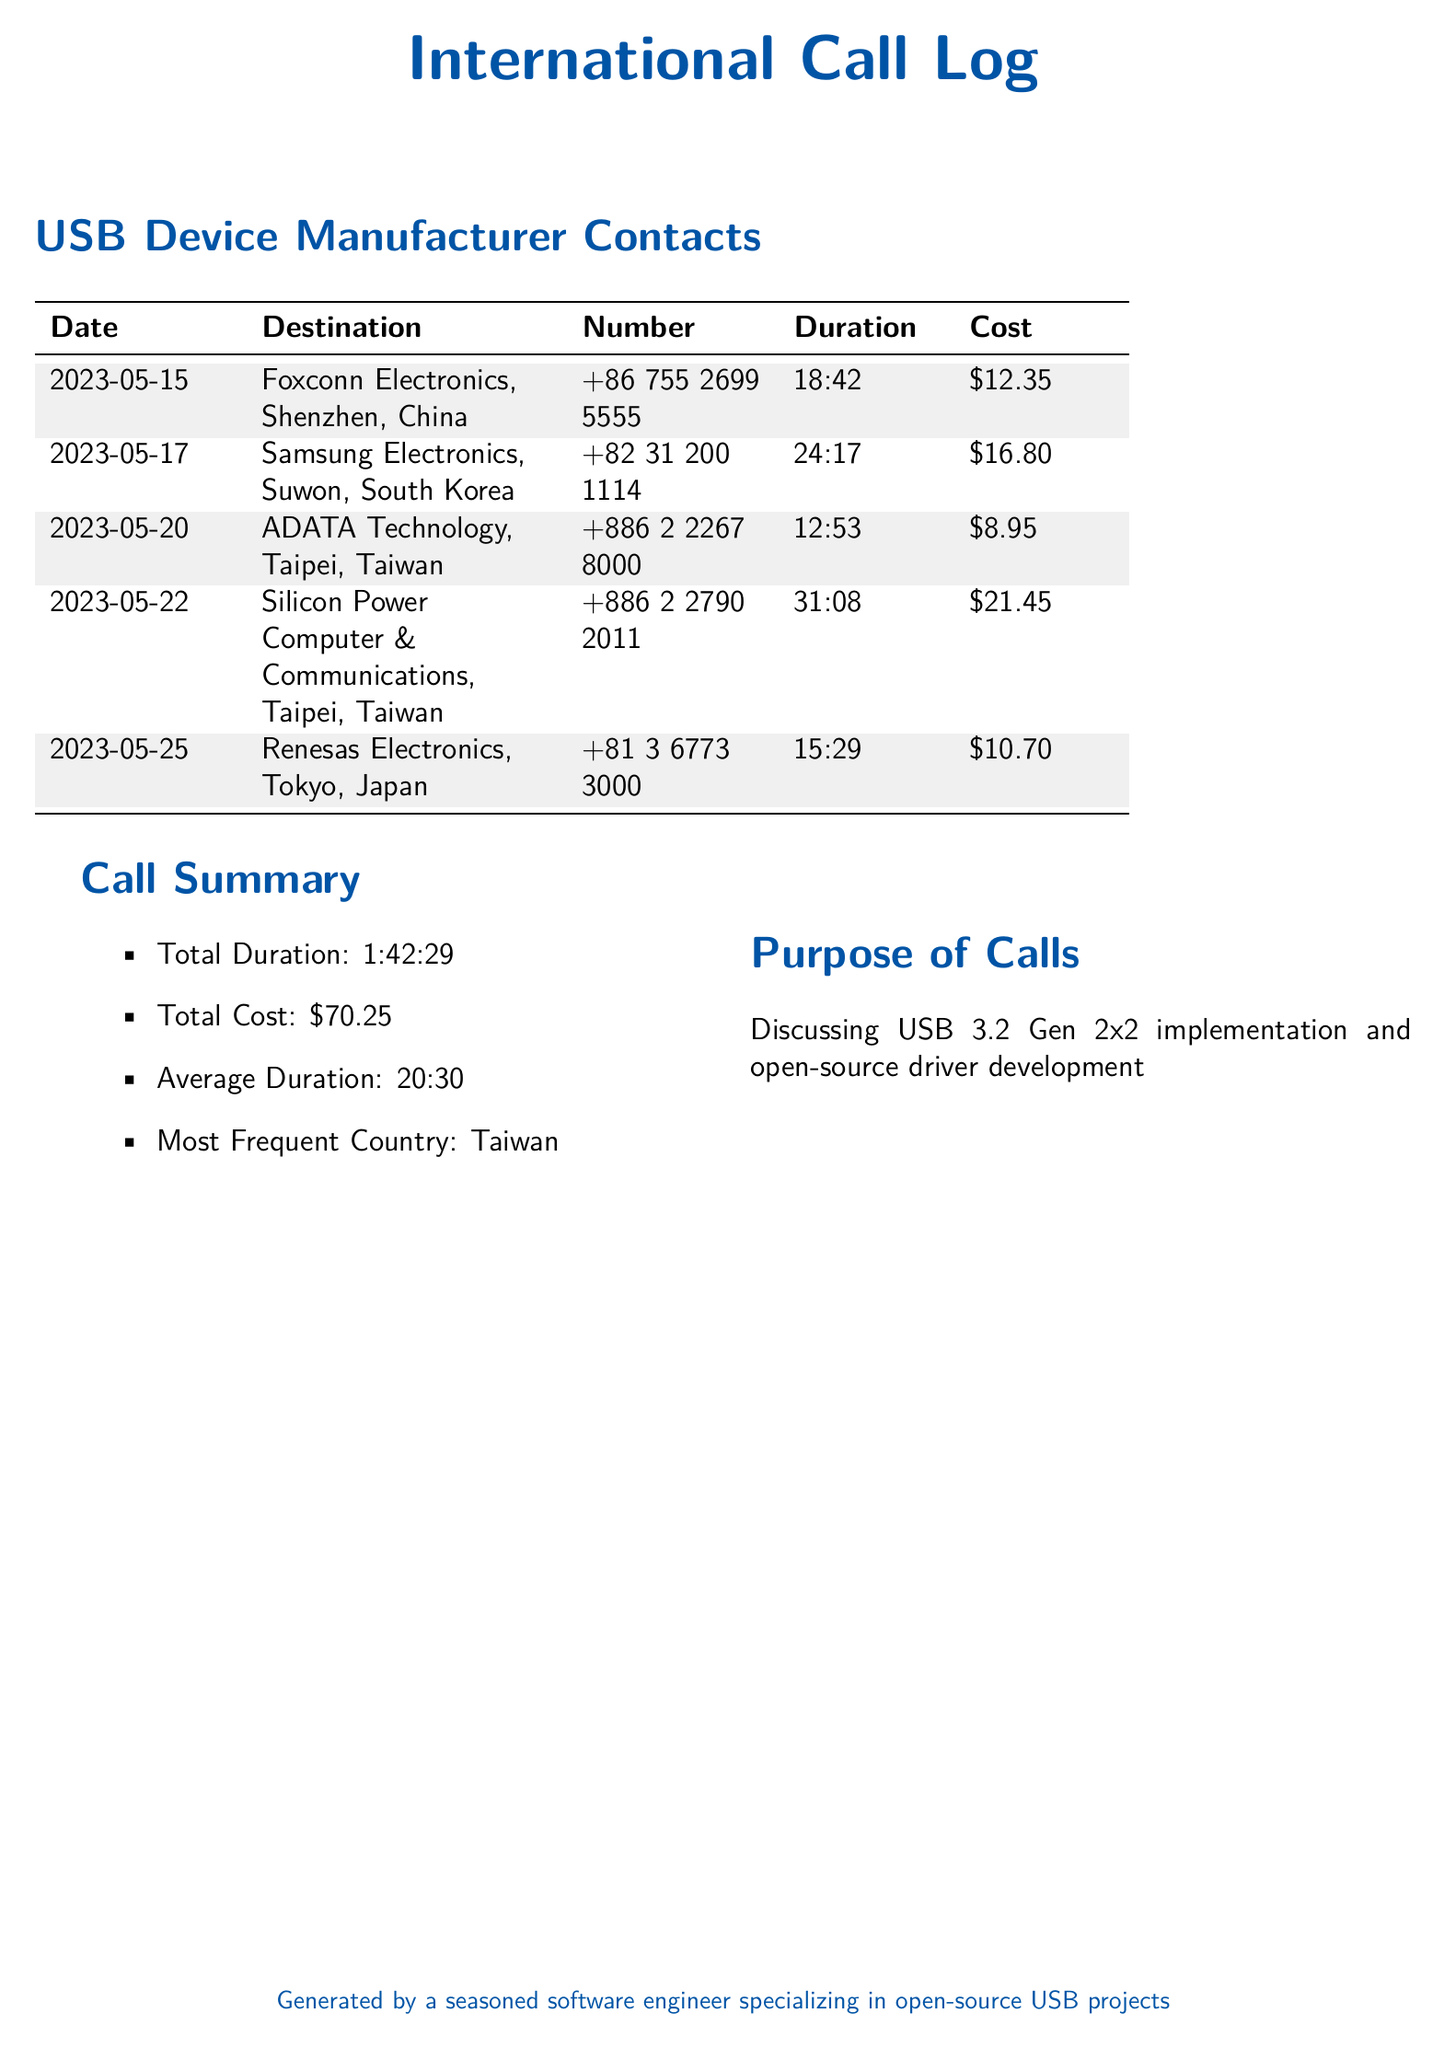What is the date of the call to Foxconn Electronics? The date of the call made to Foxconn Electronics is specified in the document as May 15, 2023.
Answer: May 15, 2023 What is the number called for Samsung Electronics? The specific number called to reach Samsung Electronics is given in the call log section of the document.
Answer: +82 31 200 1114 What was the total cost of all calls? The total cost is summed up in the Call Summary section, combining all individual call costs listed.
Answer: $70.25 Which country had the most calls made? The summary indicates that Taiwan held the highest call frequency.
Answer: Taiwan What is the duration of the call to Renesas Electronics? The duration of the call to Renesas Electronics is recorded in the call details of the log.
Answer: 15:29 What is the average duration of the calls made? The Call Summary includes the calculated average duration of all calls.
Answer: 20:30 What was the purpose of the calls? The document states the reason for these calls in the Purpose of Calls section.
Answer: Discussing USB 3.2 Gen 2x2 implementation and open-source driver development How many calls were made to Taiwanese manufacturers? By reviewing the call log, one can determine the number of calls directed to Taiwanese companies.
Answer: 2 